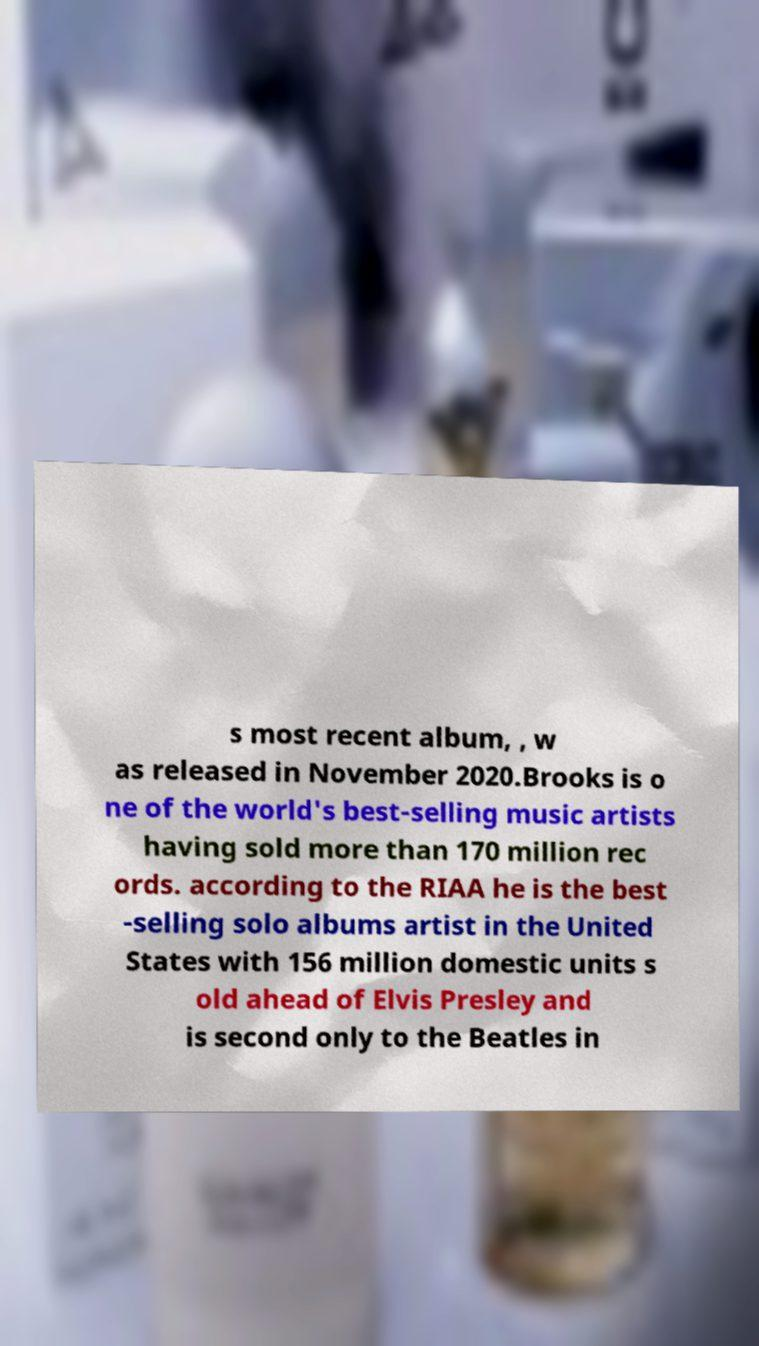Can you read and provide the text displayed in the image?This photo seems to have some interesting text. Can you extract and type it out for me? s most recent album, , w as released in November 2020.Brooks is o ne of the world's best-selling music artists having sold more than 170 million rec ords. according to the RIAA he is the best -selling solo albums artist in the United States with 156 million domestic units s old ahead of Elvis Presley and is second only to the Beatles in 